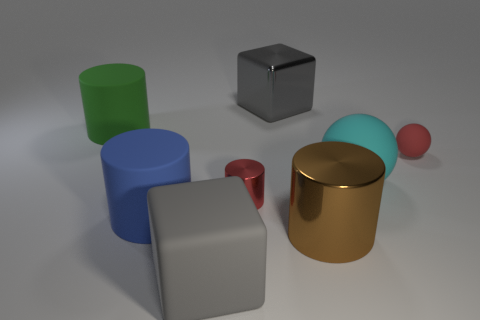Does the brown object have the same shape as the red thing that is right of the cyan thing?
Give a very brief answer. No. There is a small red object left of the red object right of the small shiny thing that is behind the blue object; what is its shape?
Your answer should be compact. Cylinder. What number of other things are made of the same material as the small cylinder?
Your answer should be compact. 2. What number of things are either large objects behind the green matte object or brown metallic blocks?
Your answer should be very brief. 1. What is the shape of the gray object to the right of the gray cube in front of the large brown object?
Your answer should be very brief. Cube. There is a small red thing in front of the large cyan ball; is its shape the same as the large cyan thing?
Your answer should be compact. No. There is a large cylinder in front of the blue cylinder; what is its color?
Provide a short and direct response. Brown. What number of spheres are blue rubber objects or large green matte things?
Offer a very short reply. 0. There is a gray block that is behind the rubber cylinder behind the blue rubber thing; how big is it?
Provide a succinct answer. Large. Does the tiny cylinder have the same color as the big shiny object in front of the red rubber ball?
Keep it short and to the point. No. 